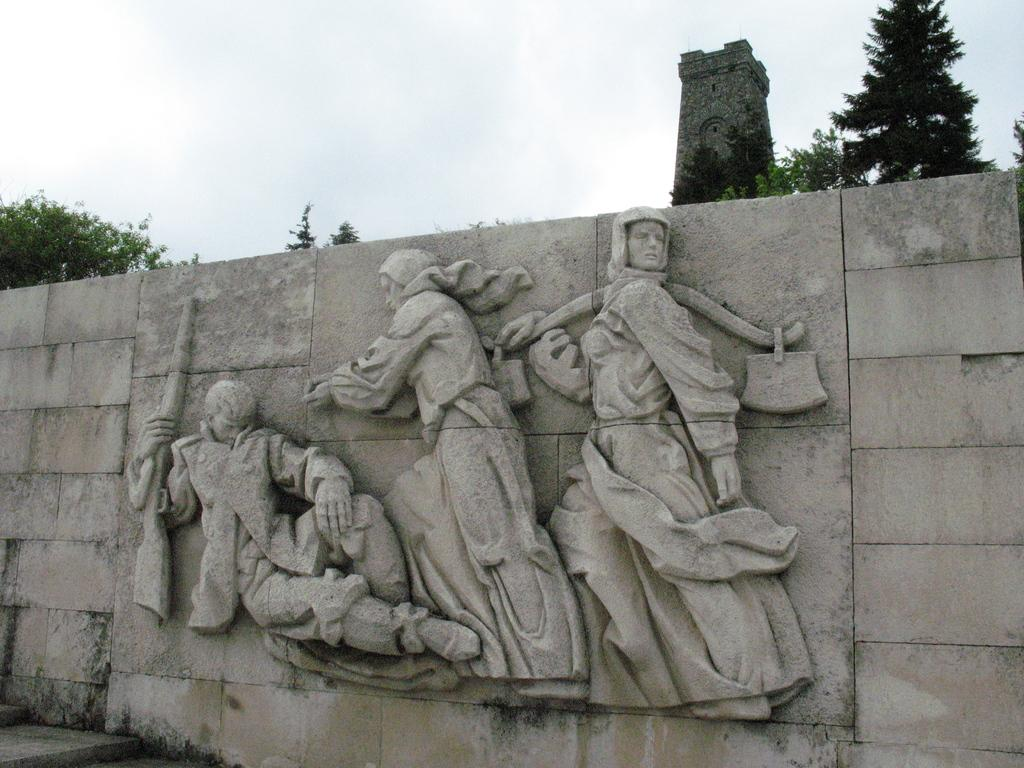What is on the wall in the image? There is a sculpture on a wall in the image. What type of natural elements can be seen in the image? Trees are visible in the image. What is visible at the top of the image? The sky is visible at the top of the image. What type of lace is being used to decorate the sculpture in the image? There is no lace present in the image; the sculpture is on a wall without any visible lace. 